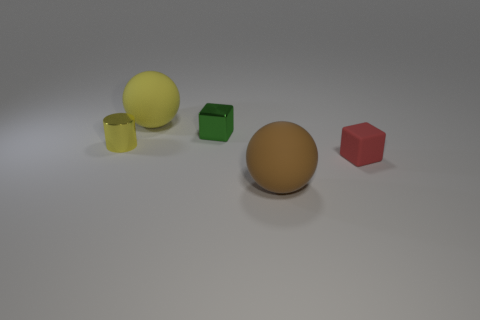The thing that is in front of the red rubber cube has what shape?
Provide a succinct answer. Sphere. There is a tiny thing on the left side of the matte sphere that is behind the red rubber cube; what is its shape?
Provide a short and direct response. Cylinder. Are there any yellow matte objects of the same shape as the big brown object?
Ensure brevity in your answer.  Yes. There is a metallic thing that is the same size as the green block; what is its shape?
Keep it short and to the point. Cylinder. There is a yellow thing that is to the left of the yellow thing behind the cylinder; are there any small yellow cylinders that are in front of it?
Your answer should be very brief. No. Are there any brown things of the same size as the shiny cylinder?
Give a very brief answer. No. There is a sphere behind the red matte object; what is its size?
Your answer should be compact. Large. There is a cube on the left side of the ball in front of the block on the left side of the red matte thing; what is its color?
Offer a terse response. Green. What color is the rubber ball that is to the left of the rubber ball in front of the small red block?
Make the answer very short. Yellow. Are there more tiny red things that are on the left side of the small green thing than large brown objects that are in front of the big yellow thing?
Give a very brief answer. No. 